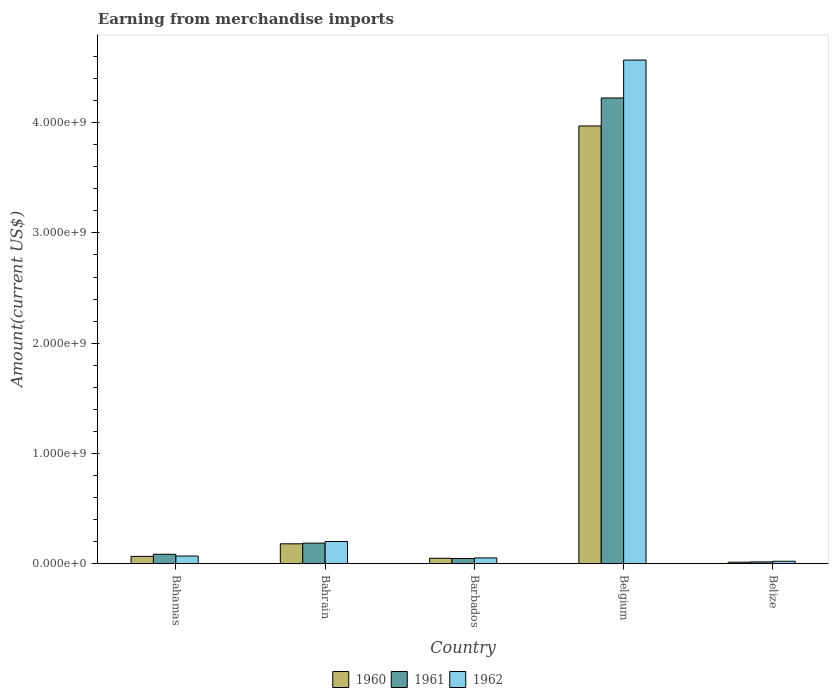How many groups of bars are there?
Offer a terse response. 5. How many bars are there on the 1st tick from the left?
Provide a short and direct response. 3. What is the label of the 5th group of bars from the left?
Provide a short and direct response. Belize. In how many cases, is the number of bars for a given country not equal to the number of legend labels?
Offer a terse response. 0. What is the amount earned from merchandise imports in 1960 in Belize?
Keep it short and to the point. 1.31e+07. Across all countries, what is the maximum amount earned from merchandise imports in 1962?
Give a very brief answer. 4.57e+09. Across all countries, what is the minimum amount earned from merchandise imports in 1960?
Give a very brief answer. 1.31e+07. In which country was the amount earned from merchandise imports in 1962 minimum?
Provide a succinct answer. Belize. What is the total amount earned from merchandise imports in 1962 in the graph?
Make the answer very short. 4.91e+09. What is the difference between the amount earned from merchandise imports in 1961 in Bahrain and that in Belgium?
Provide a succinct answer. -4.04e+09. What is the difference between the amount earned from merchandise imports in 1961 in Belize and the amount earned from merchandise imports in 1962 in Barbados?
Your answer should be compact. -3.61e+07. What is the average amount earned from merchandise imports in 1960 per country?
Provide a short and direct response. 8.56e+08. What is the difference between the amount earned from merchandise imports of/in 1962 and amount earned from merchandise imports of/in 1960 in Barbados?
Keep it short and to the point. 3.38e+06. What is the ratio of the amount earned from merchandise imports in 1962 in Bahamas to that in Belize?
Provide a succinct answer. 3.16. What is the difference between the highest and the second highest amount earned from merchandise imports in 1960?
Your response must be concise. 3.79e+09. What is the difference between the highest and the lowest amount earned from merchandise imports in 1961?
Offer a very short reply. 4.21e+09. Is the sum of the amount earned from merchandise imports in 1961 in Barbados and Belize greater than the maximum amount earned from merchandise imports in 1962 across all countries?
Keep it short and to the point. No. How many bars are there?
Offer a terse response. 15. Are all the bars in the graph horizontal?
Ensure brevity in your answer.  No. How many countries are there in the graph?
Your answer should be compact. 5. Are the values on the major ticks of Y-axis written in scientific E-notation?
Ensure brevity in your answer.  Yes. Does the graph contain any zero values?
Make the answer very short. No. How many legend labels are there?
Provide a succinct answer. 3. What is the title of the graph?
Provide a short and direct response. Earning from merchandise imports. What is the label or title of the X-axis?
Your answer should be compact. Country. What is the label or title of the Y-axis?
Keep it short and to the point. Amount(current US$). What is the Amount(current US$) of 1960 in Bahamas?
Provide a succinct answer. 6.60e+07. What is the Amount(current US$) of 1961 in Bahamas?
Your answer should be very brief. 8.50e+07. What is the Amount(current US$) of 1962 in Bahamas?
Keep it short and to the point. 6.90e+07. What is the Amount(current US$) of 1960 in Bahrain?
Keep it short and to the point. 1.80e+08. What is the Amount(current US$) in 1961 in Bahrain?
Offer a terse response. 1.86e+08. What is the Amount(current US$) of 1962 in Bahrain?
Offer a terse response. 2.01e+08. What is the Amount(current US$) in 1960 in Barbados?
Your answer should be very brief. 4.86e+07. What is the Amount(current US$) of 1961 in Barbados?
Provide a succinct answer. 4.68e+07. What is the Amount(current US$) in 1962 in Barbados?
Your answer should be very brief. 5.20e+07. What is the Amount(current US$) in 1960 in Belgium?
Provide a succinct answer. 3.97e+09. What is the Amount(current US$) in 1961 in Belgium?
Provide a succinct answer. 4.22e+09. What is the Amount(current US$) of 1962 in Belgium?
Make the answer very short. 4.57e+09. What is the Amount(current US$) of 1960 in Belize?
Your response must be concise. 1.31e+07. What is the Amount(current US$) in 1961 in Belize?
Offer a very short reply. 1.59e+07. What is the Amount(current US$) in 1962 in Belize?
Ensure brevity in your answer.  2.18e+07. Across all countries, what is the maximum Amount(current US$) in 1960?
Provide a short and direct response. 3.97e+09. Across all countries, what is the maximum Amount(current US$) of 1961?
Offer a very short reply. 4.22e+09. Across all countries, what is the maximum Amount(current US$) in 1962?
Your answer should be compact. 4.57e+09. Across all countries, what is the minimum Amount(current US$) of 1960?
Keep it short and to the point. 1.31e+07. Across all countries, what is the minimum Amount(current US$) of 1961?
Offer a very short reply. 1.59e+07. Across all countries, what is the minimum Amount(current US$) of 1962?
Make the answer very short. 2.18e+07. What is the total Amount(current US$) in 1960 in the graph?
Ensure brevity in your answer.  4.28e+09. What is the total Amount(current US$) of 1961 in the graph?
Make the answer very short. 4.56e+09. What is the total Amount(current US$) of 1962 in the graph?
Keep it short and to the point. 4.91e+09. What is the difference between the Amount(current US$) of 1960 in Bahamas and that in Bahrain?
Give a very brief answer. -1.14e+08. What is the difference between the Amount(current US$) in 1961 in Bahamas and that in Bahrain?
Offer a very short reply. -1.01e+08. What is the difference between the Amount(current US$) in 1962 in Bahamas and that in Bahrain?
Keep it short and to the point. -1.32e+08. What is the difference between the Amount(current US$) of 1960 in Bahamas and that in Barbados?
Give a very brief answer. 1.74e+07. What is the difference between the Amount(current US$) in 1961 in Bahamas and that in Barbados?
Your answer should be very brief. 3.82e+07. What is the difference between the Amount(current US$) of 1962 in Bahamas and that in Barbados?
Make the answer very short. 1.70e+07. What is the difference between the Amount(current US$) of 1960 in Bahamas and that in Belgium?
Provide a succinct answer. -3.90e+09. What is the difference between the Amount(current US$) in 1961 in Bahamas and that in Belgium?
Your response must be concise. -4.14e+09. What is the difference between the Amount(current US$) in 1962 in Bahamas and that in Belgium?
Make the answer very short. -4.50e+09. What is the difference between the Amount(current US$) of 1960 in Bahamas and that in Belize?
Your answer should be compact. 5.29e+07. What is the difference between the Amount(current US$) of 1961 in Bahamas and that in Belize?
Ensure brevity in your answer.  6.91e+07. What is the difference between the Amount(current US$) in 1962 in Bahamas and that in Belize?
Keep it short and to the point. 4.72e+07. What is the difference between the Amount(current US$) of 1960 in Bahrain and that in Barbados?
Your response must be concise. 1.31e+08. What is the difference between the Amount(current US$) of 1961 in Bahrain and that in Barbados?
Your answer should be very brief. 1.39e+08. What is the difference between the Amount(current US$) of 1962 in Bahrain and that in Barbados?
Your answer should be very brief. 1.49e+08. What is the difference between the Amount(current US$) of 1960 in Bahrain and that in Belgium?
Offer a very short reply. -3.79e+09. What is the difference between the Amount(current US$) in 1961 in Bahrain and that in Belgium?
Keep it short and to the point. -4.04e+09. What is the difference between the Amount(current US$) in 1962 in Bahrain and that in Belgium?
Give a very brief answer. -4.37e+09. What is the difference between the Amount(current US$) in 1960 in Bahrain and that in Belize?
Your answer should be very brief. 1.67e+08. What is the difference between the Amount(current US$) of 1961 in Bahrain and that in Belize?
Provide a succinct answer. 1.70e+08. What is the difference between the Amount(current US$) of 1962 in Bahrain and that in Belize?
Your answer should be compact. 1.79e+08. What is the difference between the Amount(current US$) in 1960 in Barbados and that in Belgium?
Ensure brevity in your answer.  -3.92e+09. What is the difference between the Amount(current US$) in 1961 in Barbados and that in Belgium?
Your response must be concise. -4.18e+09. What is the difference between the Amount(current US$) in 1962 in Barbados and that in Belgium?
Keep it short and to the point. -4.52e+09. What is the difference between the Amount(current US$) of 1960 in Barbados and that in Belize?
Your answer should be very brief. 3.54e+07. What is the difference between the Amount(current US$) in 1961 in Barbados and that in Belize?
Provide a short and direct response. 3.09e+07. What is the difference between the Amount(current US$) in 1962 in Barbados and that in Belize?
Your answer should be compact. 3.01e+07. What is the difference between the Amount(current US$) of 1960 in Belgium and that in Belize?
Give a very brief answer. 3.96e+09. What is the difference between the Amount(current US$) of 1961 in Belgium and that in Belize?
Make the answer very short. 4.21e+09. What is the difference between the Amount(current US$) of 1962 in Belgium and that in Belize?
Your answer should be very brief. 4.55e+09. What is the difference between the Amount(current US$) of 1960 in Bahamas and the Amount(current US$) of 1961 in Bahrain?
Your answer should be very brief. -1.20e+08. What is the difference between the Amount(current US$) of 1960 in Bahamas and the Amount(current US$) of 1962 in Bahrain?
Provide a short and direct response. -1.35e+08. What is the difference between the Amount(current US$) in 1961 in Bahamas and the Amount(current US$) in 1962 in Bahrain?
Offer a very short reply. -1.16e+08. What is the difference between the Amount(current US$) of 1960 in Bahamas and the Amount(current US$) of 1961 in Barbados?
Your answer should be very brief. 1.92e+07. What is the difference between the Amount(current US$) of 1960 in Bahamas and the Amount(current US$) of 1962 in Barbados?
Provide a short and direct response. 1.40e+07. What is the difference between the Amount(current US$) of 1961 in Bahamas and the Amount(current US$) of 1962 in Barbados?
Your answer should be very brief. 3.30e+07. What is the difference between the Amount(current US$) of 1960 in Bahamas and the Amount(current US$) of 1961 in Belgium?
Make the answer very short. -4.16e+09. What is the difference between the Amount(current US$) in 1960 in Bahamas and the Amount(current US$) in 1962 in Belgium?
Give a very brief answer. -4.50e+09. What is the difference between the Amount(current US$) in 1961 in Bahamas and the Amount(current US$) in 1962 in Belgium?
Your response must be concise. -4.48e+09. What is the difference between the Amount(current US$) in 1960 in Bahamas and the Amount(current US$) in 1961 in Belize?
Offer a very short reply. 5.01e+07. What is the difference between the Amount(current US$) of 1960 in Bahamas and the Amount(current US$) of 1962 in Belize?
Offer a very short reply. 4.42e+07. What is the difference between the Amount(current US$) of 1961 in Bahamas and the Amount(current US$) of 1962 in Belize?
Offer a terse response. 6.32e+07. What is the difference between the Amount(current US$) of 1960 in Bahrain and the Amount(current US$) of 1961 in Barbados?
Give a very brief answer. 1.33e+08. What is the difference between the Amount(current US$) of 1960 in Bahrain and the Amount(current US$) of 1962 in Barbados?
Offer a very short reply. 1.28e+08. What is the difference between the Amount(current US$) of 1961 in Bahrain and the Amount(current US$) of 1962 in Barbados?
Your response must be concise. 1.34e+08. What is the difference between the Amount(current US$) in 1960 in Bahrain and the Amount(current US$) in 1961 in Belgium?
Keep it short and to the point. -4.04e+09. What is the difference between the Amount(current US$) of 1960 in Bahrain and the Amount(current US$) of 1962 in Belgium?
Give a very brief answer. -4.39e+09. What is the difference between the Amount(current US$) in 1961 in Bahrain and the Amount(current US$) in 1962 in Belgium?
Ensure brevity in your answer.  -4.38e+09. What is the difference between the Amount(current US$) in 1960 in Bahrain and the Amount(current US$) in 1961 in Belize?
Offer a terse response. 1.64e+08. What is the difference between the Amount(current US$) of 1960 in Bahrain and the Amount(current US$) of 1962 in Belize?
Ensure brevity in your answer.  1.58e+08. What is the difference between the Amount(current US$) of 1961 in Bahrain and the Amount(current US$) of 1962 in Belize?
Your answer should be very brief. 1.64e+08. What is the difference between the Amount(current US$) of 1960 in Barbados and the Amount(current US$) of 1961 in Belgium?
Your answer should be compact. -4.18e+09. What is the difference between the Amount(current US$) in 1960 in Barbados and the Amount(current US$) in 1962 in Belgium?
Offer a very short reply. -4.52e+09. What is the difference between the Amount(current US$) in 1961 in Barbados and the Amount(current US$) in 1962 in Belgium?
Give a very brief answer. -4.52e+09. What is the difference between the Amount(current US$) in 1960 in Barbados and the Amount(current US$) in 1961 in Belize?
Your answer should be compact. 3.27e+07. What is the difference between the Amount(current US$) of 1960 in Barbados and the Amount(current US$) of 1962 in Belize?
Provide a short and direct response. 2.68e+07. What is the difference between the Amount(current US$) of 1961 in Barbados and the Amount(current US$) of 1962 in Belize?
Your response must be concise. 2.50e+07. What is the difference between the Amount(current US$) in 1960 in Belgium and the Amount(current US$) in 1961 in Belize?
Offer a very short reply. 3.95e+09. What is the difference between the Amount(current US$) in 1960 in Belgium and the Amount(current US$) in 1962 in Belize?
Make the answer very short. 3.95e+09. What is the difference between the Amount(current US$) in 1961 in Belgium and the Amount(current US$) in 1962 in Belize?
Make the answer very short. 4.20e+09. What is the average Amount(current US$) in 1960 per country?
Offer a terse response. 8.56e+08. What is the average Amount(current US$) of 1961 per country?
Your answer should be very brief. 9.12e+08. What is the average Amount(current US$) in 1962 per country?
Keep it short and to the point. 9.82e+08. What is the difference between the Amount(current US$) in 1960 and Amount(current US$) in 1961 in Bahamas?
Offer a very short reply. -1.90e+07. What is the difference between the Amount(current US$) in 1960 and Amount(current US$) in 1962 in Bahamas?
Offer a terse response. -3.00e+06. What is the difference between the Amount(current US$) of 1961 and Amount(current US$) of 1962 in Bahamas?
Offer a very short reply. 1.60e+07. What is the difference between the Amount(current US$) of 1960 and Amount(current US$) of 1961 in Bahrain?
Make the answer very short. -6.00e+06. What is the difference between the Amount(current US$) of 1960 and Amount(current US$) of 1962 in Bahrain?
Your answer should be compact. -2.10e+07. What is the difference between the Amount(current US$) of 1961 and Amount(current US$) of 1962 in Bahrain?
Keep it short and to the point. -1.50e+07. What is the difference between the Amount(current US$) of 1960 and Amount(current US$) of 1961 in Barbados?
Provide a short and direct response. 1.77e+06. What is the difference between the Amount(current US$) of 1960 and Amount(current US$) of 1962 in Barbados?
Your answer should be very brief. -3.38e+06. What is the difference between the Amount(current US$) of 1961 and Amount(current US$) of 1962 in Barbados?
Offer a terse response. -5.15e+06. What is the difference between the Amount(current US$) of 1960 and Amount(current US$) of 1961 in Belgium?
Offer a terse response. -2.54e+08. What is the difference between the Amount(current US$) in 1960 and Amount(current US$) in 1962 in Belgium?
Your response must be concise. -5.98e+08. What is the difference between the Amount(current US$) of 1961 and Amount(current US$) of 1962 in Belgium?
Offer a very short reply. -3.44e+08. What is the difference between the Amount(current US$) in 1960 and Amount(current US$) in 1961 in Belize?
Offer a very short reply. -2.75e+06. What is the difference between the Amount(current US$) of 1960 and Amount(current US$) of 1962 in Belize?
Your answer should be compact. -8.69e+06. What is the difference between the Amount(current US$) of 1961 and Amount(current US$) of 1962 in Belize?
Ensure brevity in your answer.  -5.94e+06. What is the ratio of the Amount(current US$) in 1960 in Bahamas to that in Bahrain?
Your response must be concise. 0.37. What is the ratio of the Amount(current US$) in 1961 in Bahamas to that in Bahrain?
Provide a succinct answer. 0.46. What is the ratio of the Amount(current US$) of 1962 in Bahamas to that in Bahrain?
Provide a short and direct response. 0.34. What is the ratio of the Amount(current US$) in 1960 in Bahamas to that in Barbados?
Your answer should be compact. 1.36. What is the ratio of the Amount(current US$) in 1961 in Bahamas to that in Barbados?
Ensure brevity in your answer.  1.82. What is the ratio of the Amount(current US$) in 1962 in Bahamas to that in Barbados?
Your answer should be compact. 1.33. What is the ratio of the Amount(current US$) of 1960 in Bahamas to that in Belgium?
Provide a short and direct response. 0.02. What is the ratio of the Amount(current US$) in 1961 in Bahamas to that in Belgium?
Make the answer very short. 0.02. What is the ratio of the Amount(current US$) of 1962 in Bahamas to that in Belgium?
Your response must be concise. 0.02. What is the ratio of the Amount(current US$) of 1960 in Bahamas to that in Belize?
Offer a terse response. 5.02. What is the ratio of the Amount(current US$) in 1961 in Bahamas to that in Belize?
Give a very brief answer. 5.35. What is the ratio of the Amount(current US$) of 1962 in Bahamas to that in Belize?
Keep it short and to the point. 3.16. What is the ratio of the Amount(current US$) of 1960 in Bahrain to that in Barbados?
Provide a short and direct response. 3.7. What is the ratio of the Amount(current US$) of 1961 in Bahrain to that in Barbados?
Ensure brevity in your answer.  3.97. What is the ratio of the Amount(current US$) of 1962 in Bahrain to that in Barbados?
Provide a succinct answer. 3.87. What is the ratio of the Amount(current US$) in 1960 in Bahrain to that in Belgium?
Make the answer very short. 0.05. What is the ratio of the Amount(current US$) of 1961 in Bahrain to that in Belgium?
Provide a succinct answer. 0.04. What is the ratio of the Amount(current US$) in 1962 in Bahrain to that in Belgium?
Your answer should be compact. 0.04. What is the ratio of the Amount(current US$) of 1960 in Bahrain to that in Belize?
Provide a short and direct response. 13.69. What is the ratio of the Amount(current US$) of 1961 in Bahrain to that in Belize?
Offer a very short reply. 11.7. What is the ratio of the Amount(current US$) of 1962 in Bahrain to that in Belize?
Offer a terse response. 9.2. What is the ratio of the Amount(current US$) in 1960 in Barbados to that in Belgium?
Provide a short and direct response. 0.01. What is the ratio of the Amount(current US$) of 1961 in Barbados to that in Belgium?
Ensure brevity in your answer.  0.01. What is the ratio of the Amount(current US$) in 1962 in Barbados to that in Belgium?
Your answer should be very brief. 0.01. What is the ratio of the Amount(current US$) of 1960 in Barbados to that in Belize?
Your response must be concise. 3.7. What is the ratio of the Amount(current US$) of 1961 in Barbados to that in Belize?
Offer a terse response. 2.95. What is the ratio of the Amount(current US$) in 1962 in Barbados to that in Belize?
Offer a very short reply. 2.38. What is the ratio of the Amount(current US$) of 1960 in Belgium to that in Belize?
Offer a terse response. 301.99. What is the ratio of the Amount(current US$) in 1961 in Belgium to that in Belize?
Your answer should be compact. 265.71. What is the ratio of the Amount(current US$) of 1962 in Belgium to that in Belize?
Offer a very short reply. 209.16. What is the difference between the highest and the second highest Amount(current US$) of 1960?
Ensure brevity in your answer.  3.79e+09. What is the difference between the highest and the second highest Amount(current US$) of 1961?
Your answer should be compact. 4.04e+09. What is the difference between the highest and the second highest Amount(current US$) of 1962?
Offer a very short reply. 4.37e+09. What is the difference between the highest and the lowest Amount(current US$) in 1960?
Your answer should be very brief. 3.96e+09. What is the difference between the highest and the lowest Amount(current US$) in 1961?
Give a very brief answer. 4.21e+09. What is the difference between the highest and the lowest Amount(current US$) of 1962?
Provide a succinct answer. 4.55e+09. 